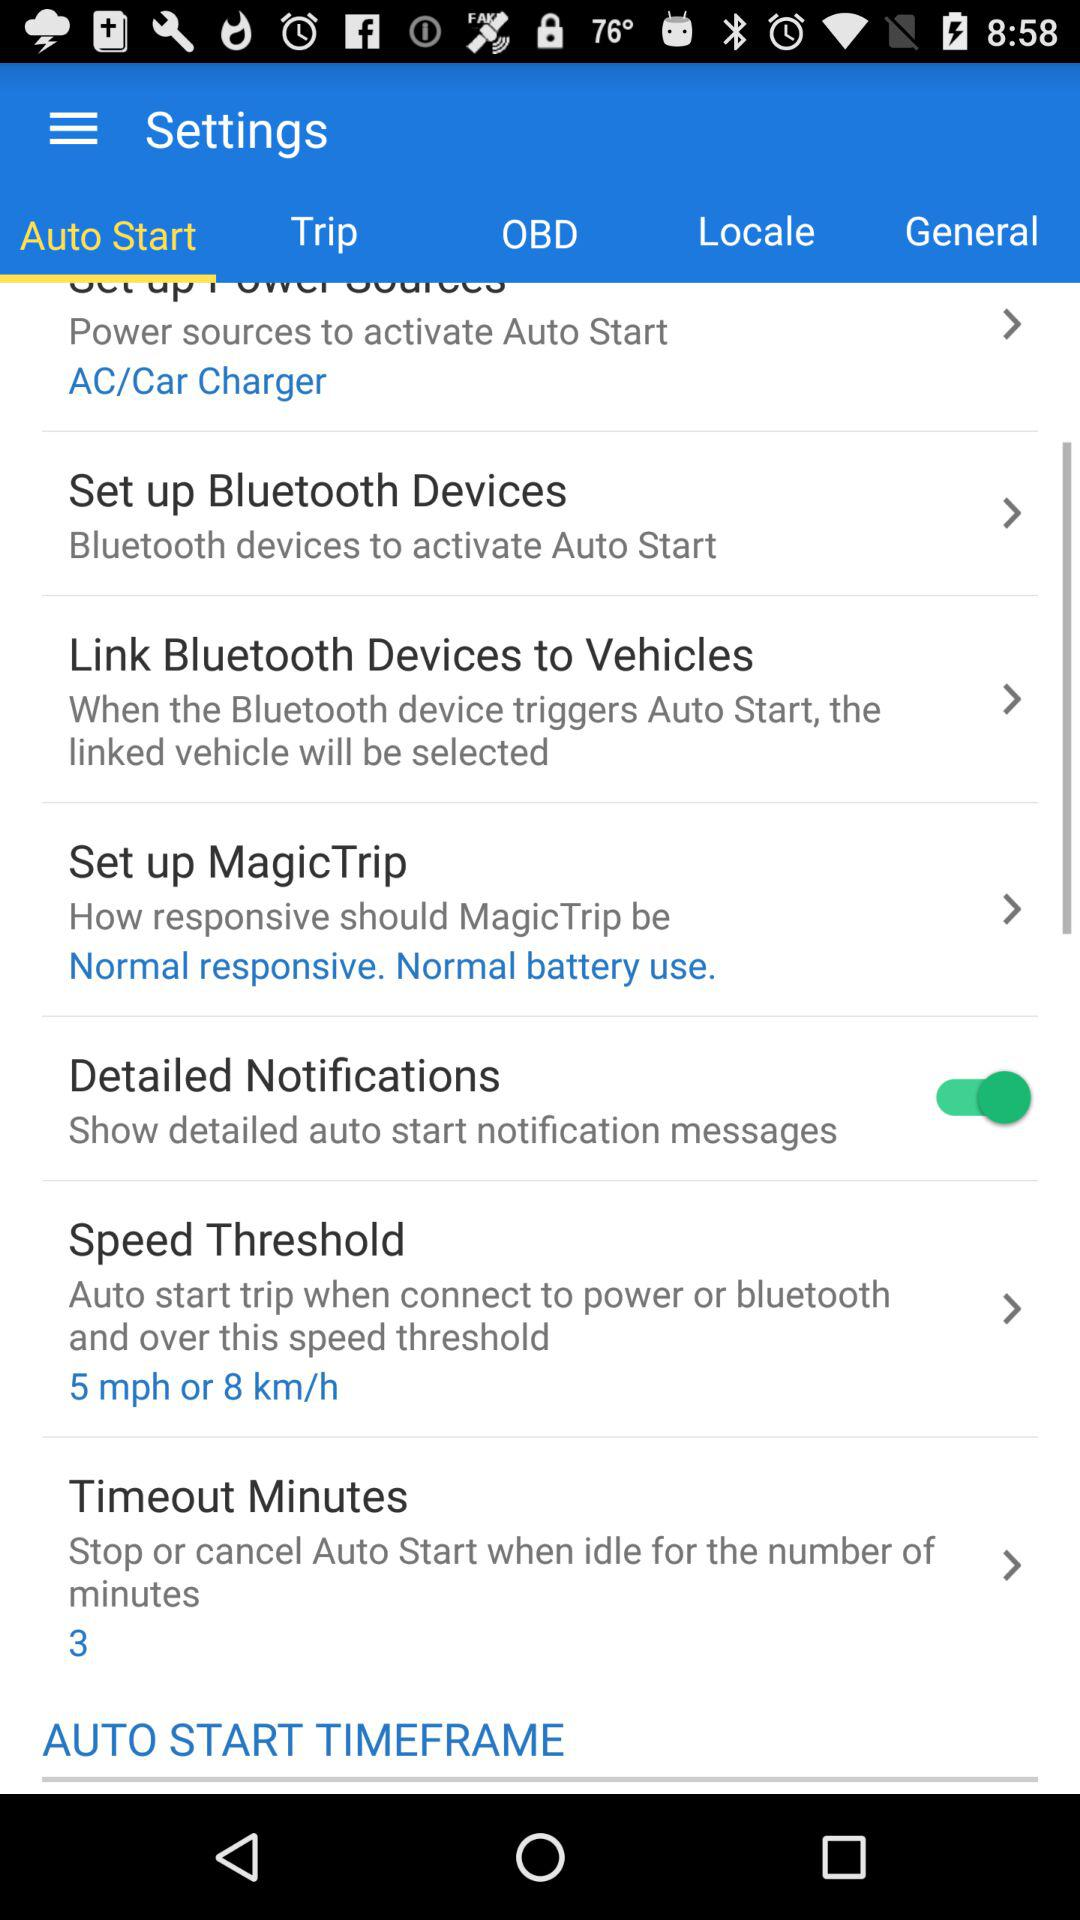What will happen if a speed threshold is selected?
When the provided information is insufficient, respond with <no answer>. <no answer> 